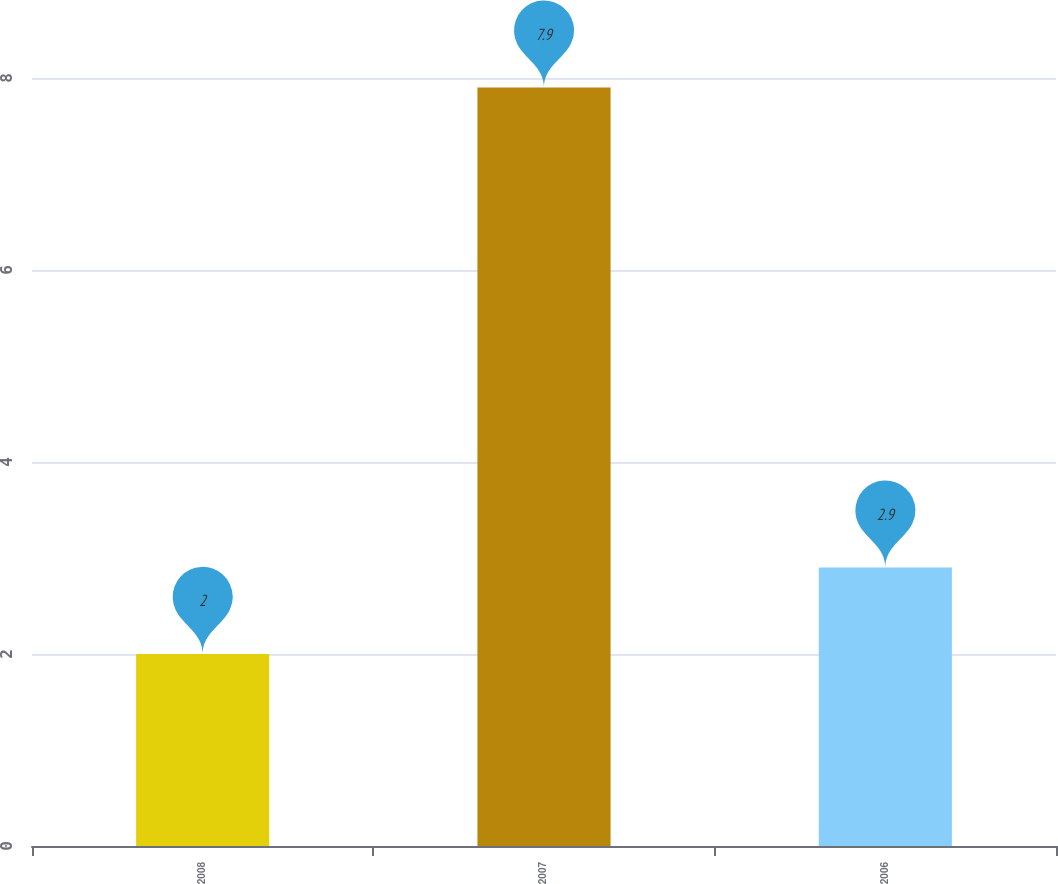<chart> <loc_0><loc_0><loc_500><loc_500><bar_chart><fcel>2008<fcel>2007<fcel>2006<nl><fcel>2<fcel>7.9<fcel>2.9<nl></chart> 